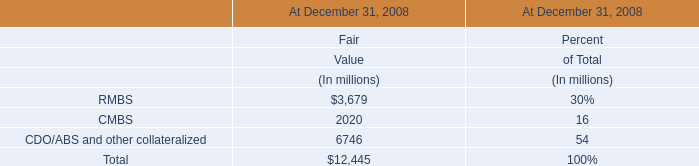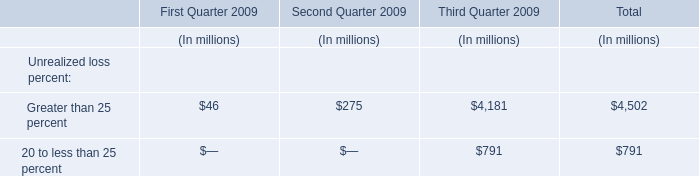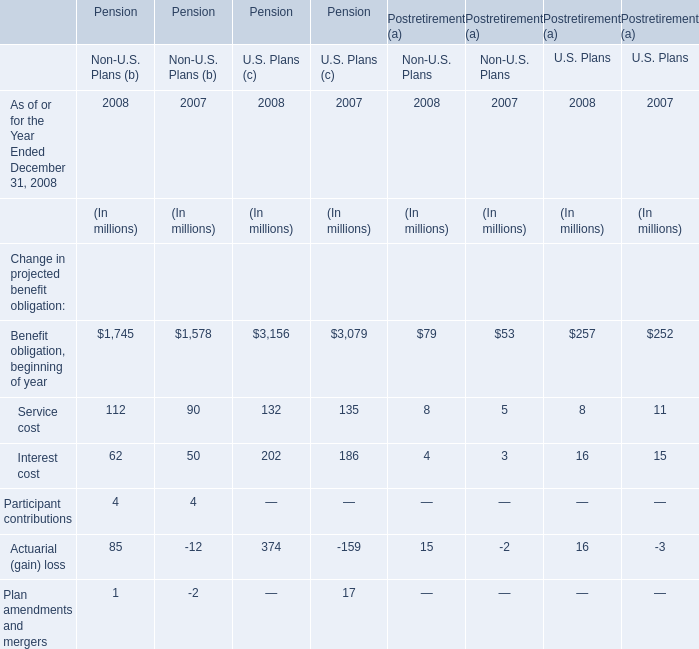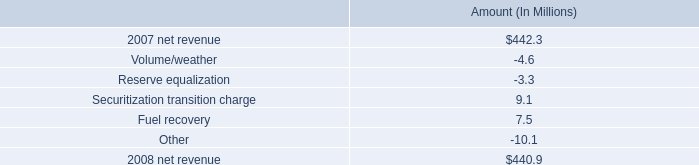what is the growth rate in net revenue in 2008 for entergy texas , inc.? 
Computations: ((440.9 - 442.3) / 442.3)
Answer: -0.00317. 